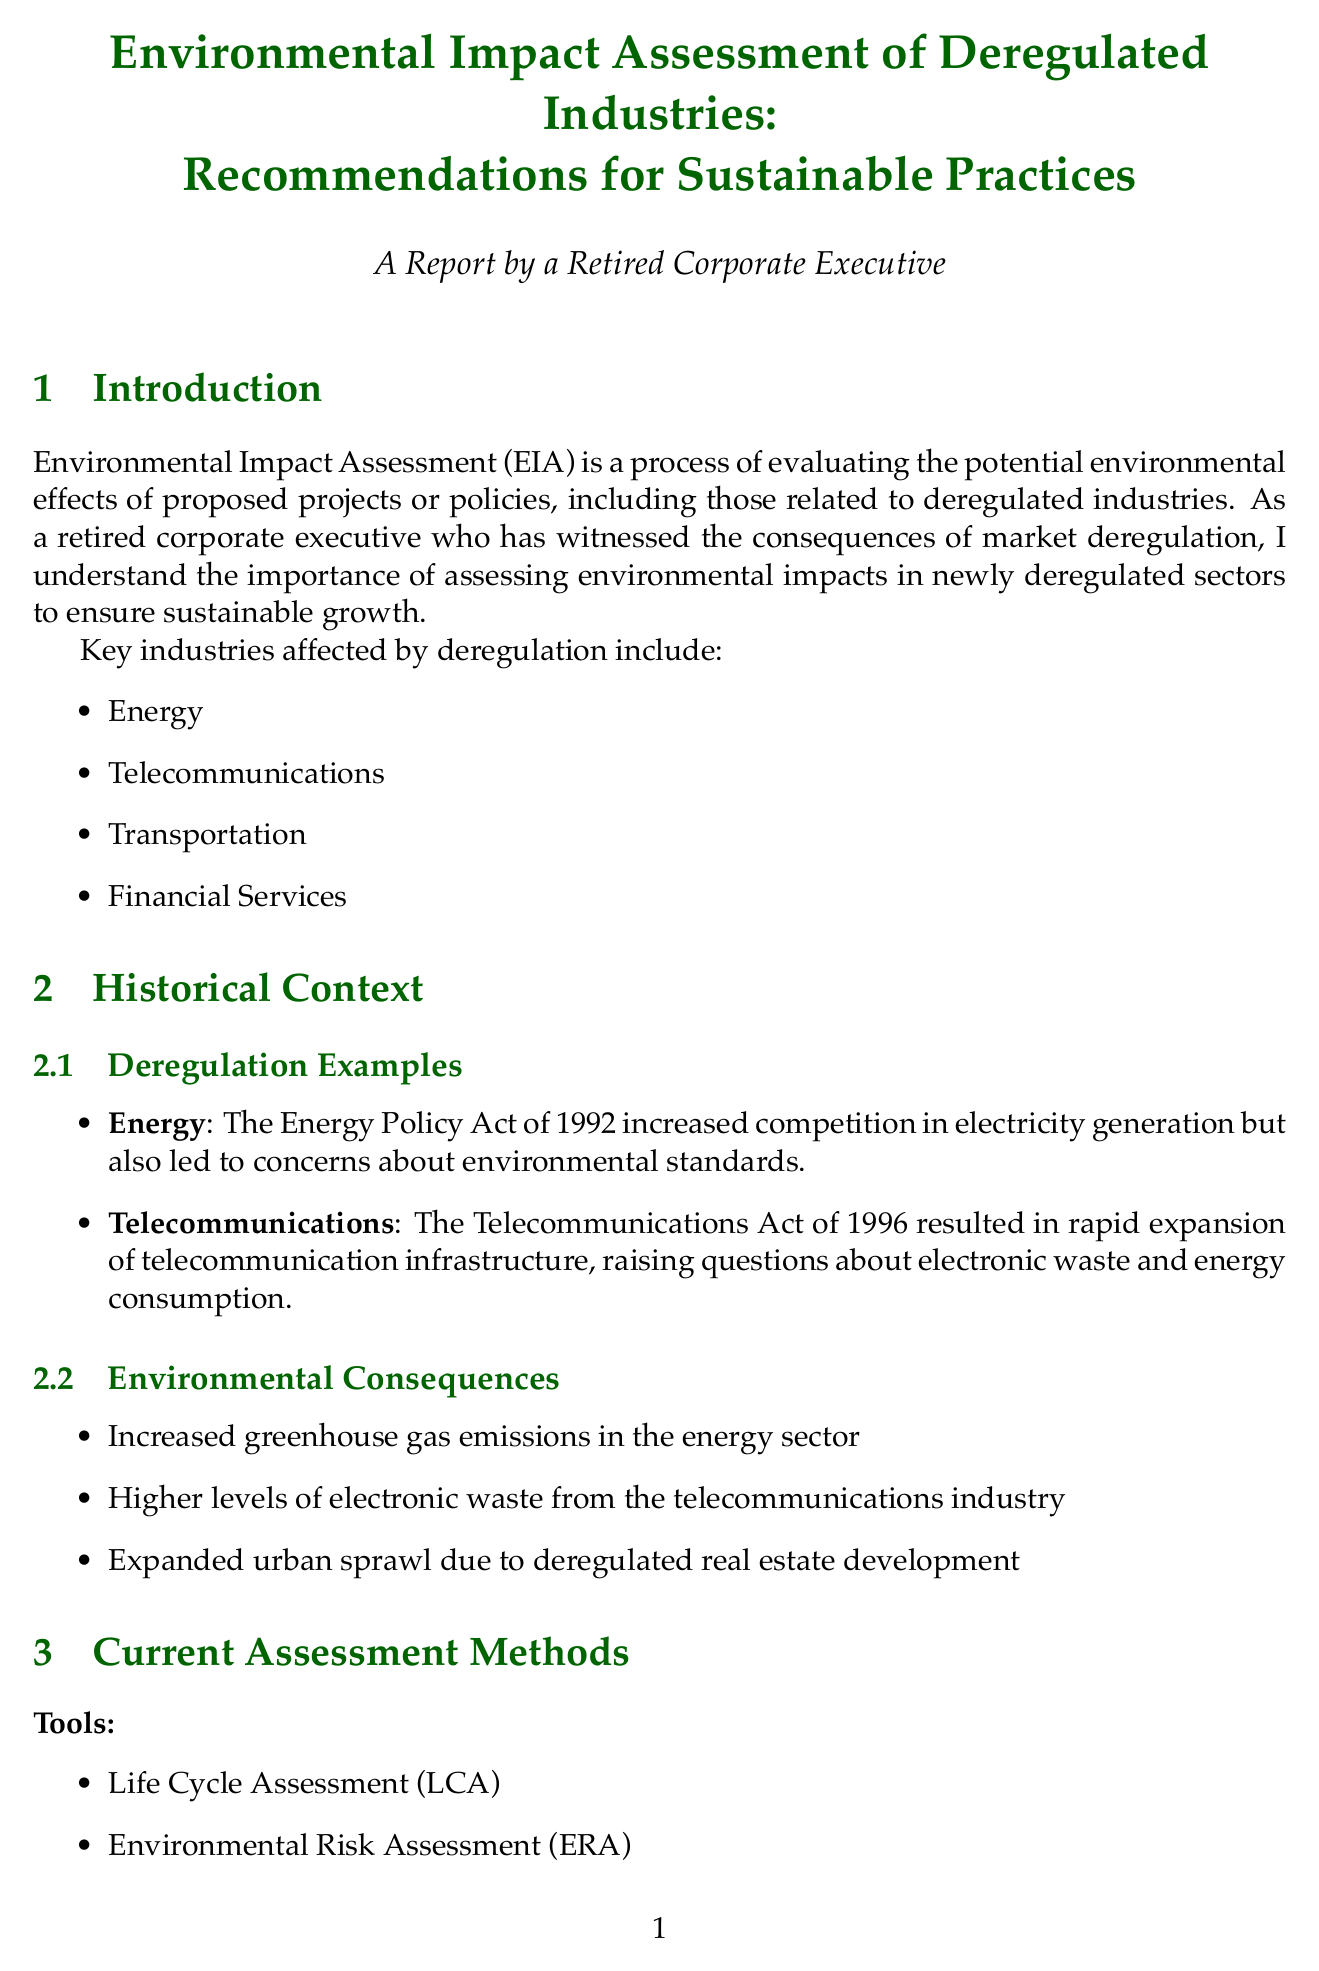What is the definition of EIA? The definition of EIA is presented in the introduction section of the document.
Answer: Environmental Impact Assessment (EIA) is a process of evaluating the potential environmental effects of proposed projects or policies, including those related to deregulated industries Which act increased competition in the energy sector? The document lists the Energy Policy Act of 1992 as the act that increased competition in electricity generation.
Answer: The Energy Policy Act of 1992 What are the key industries affected by deregulation? The introduction section lists four key industries affected by deregulation.
Answer: Energy, Telecommunications, Transportation, Financial Services What company initiated a transition to renewable energy sources? The case studies section identifies NextEra Energy as the company that transitioned to renewable energy sources.
Answer: NextEra Energy What is one challenge mentioned regarding current assessment methods? The document lists challenges faced in current assessment methods and asks for a specific challenge.
Answer: Lack of historical data in newly deregulated industries What sustainable practice involves designing products for reuse? The document specifies practices that promote sustainability and one of them emphasizes product design.
Answer: Adopt circular economy principles Which regulatory act exists in the United States? The document lists regulatory frameworks, including one specifically from the United States.
Answer: National Environmental Policy Act (NEPA) Name one emerging trend in environmental assessments. The future outlook section mentions trends related to environmental impact assessments and asks for an example.
Answer: Integration of artificial intelligence in environmental impact prediction What is one recommendation for sustainable practices? The recommendations section outlines various practices aimed at sustainability and requests just one.
Answer: Implement green supply chain management 